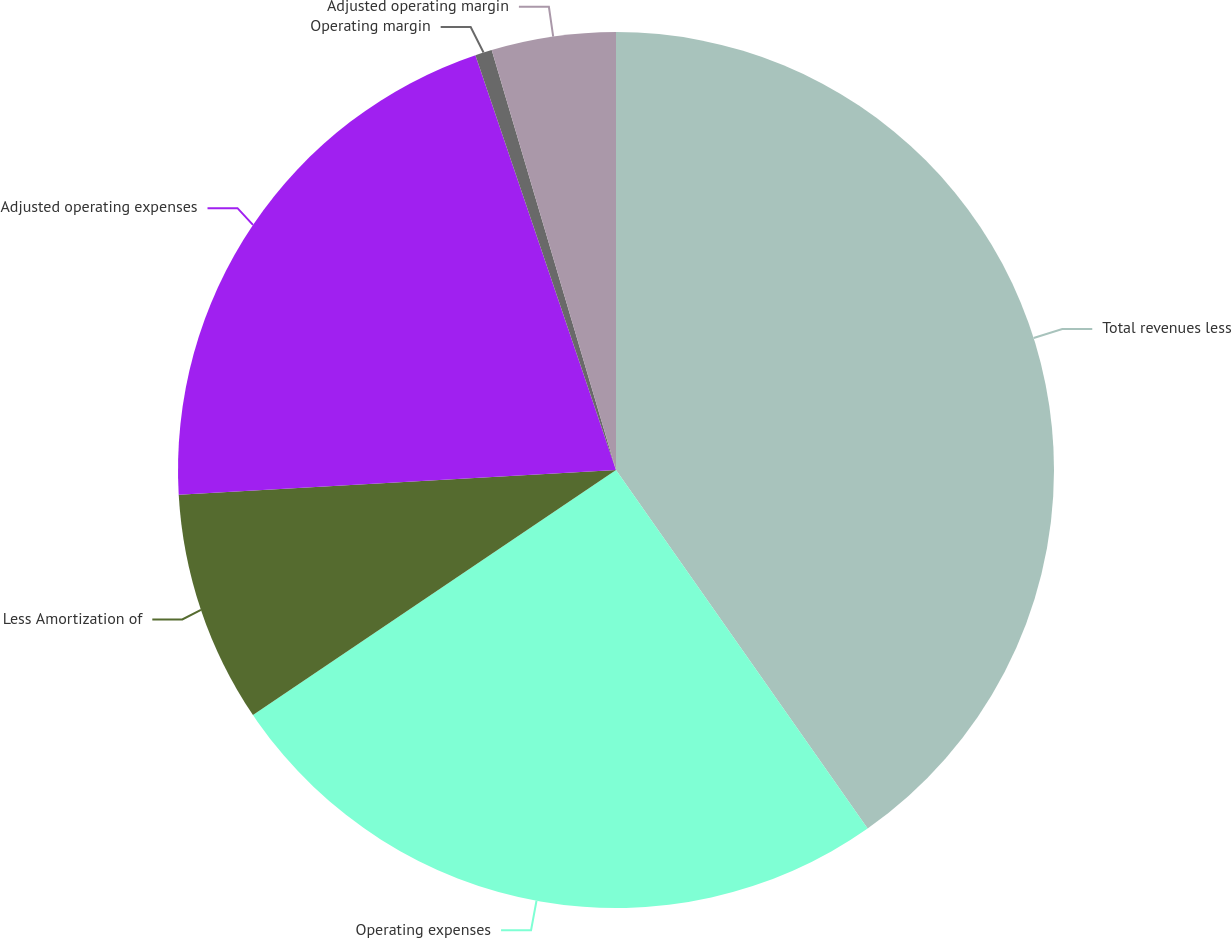Convert chart to OTSL. <chart><loc_0><loc_0><loc_500><loc_500><pie_chart><fcel>Total revenues less<fcel>Operating expenses<fcel>Less Amortization of<fcel>Adjusted operating expenses<fcel>Operating margin<fcel>Adjusted operating margin<nl><fcel>40.26%<fcel>25.29%<fcel>8.55%<fcel>20.7%<fcel>0.62%<fcel>4.58%<nl></chart> 